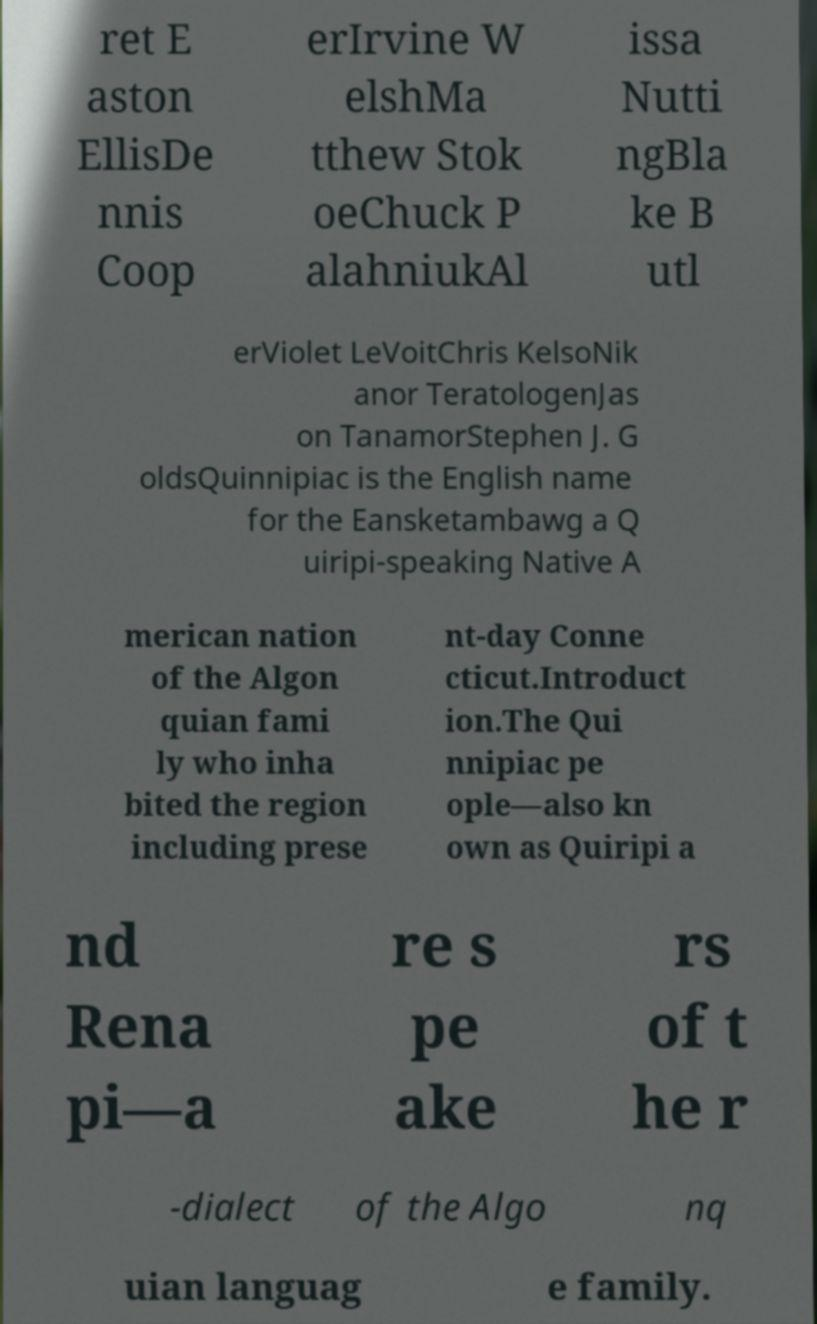Could you assist in decoding the text presented in this image and type it out clearly? ret E aston EllisDe nnis Coop erIrvine W elshMa tthew Stok oeChuck P alahniukAl issa Nutti ngBla ke B utl erViolet LeVoitChris KelsoNik anor TeratologenJas on TanamorStephen J. G oldsQuinnipiac is the English name for the Eansketambawg a Q uiripi-speaking Native A merican nation of the Algon quian fami ly who inha bited the region including prese nt-day Conne cticut.Introduct ion.The Qui nnipiac pe ople—also kn own as Quiripi a nd Rena pi—a re s pe ake rs of t he r -dialect of the Algo nq uian languag e family. 